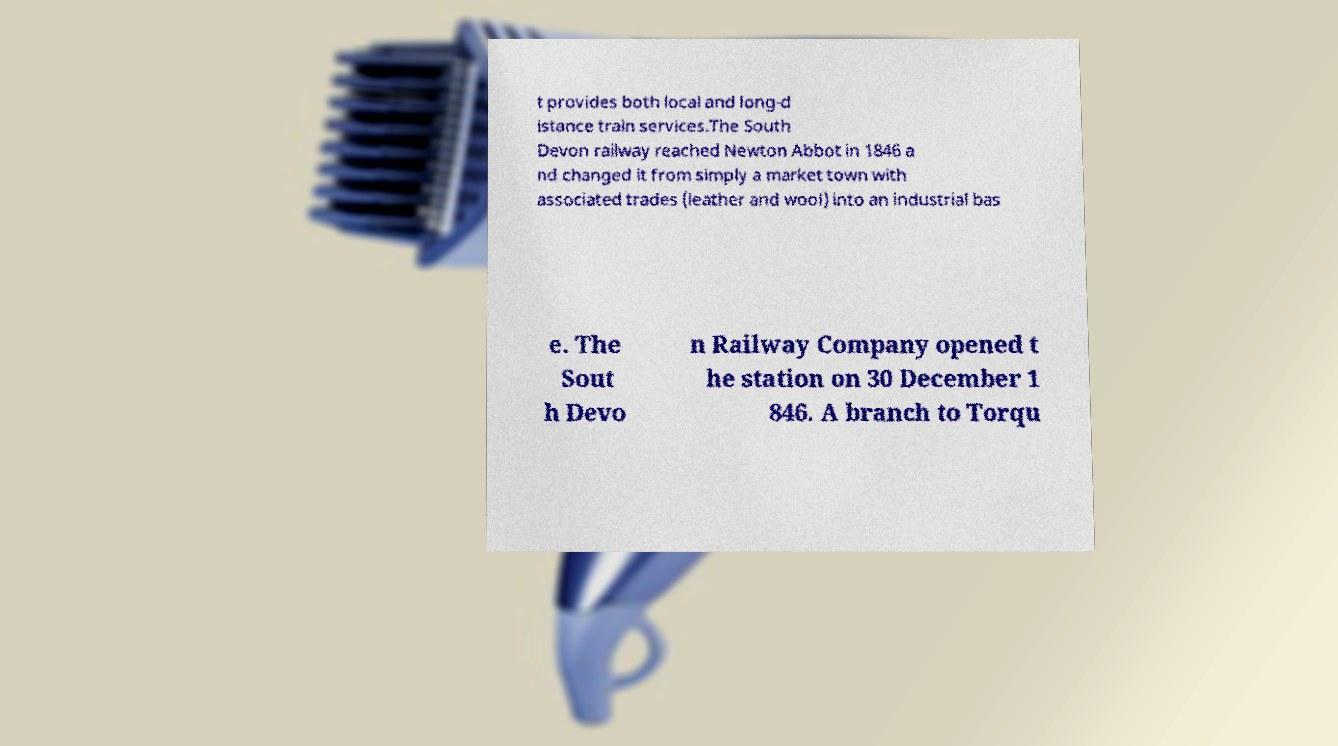I need the written content from this picture converted into text. Can you do that? t provides both local and long-d istance train services.The South Devon railway reached Newton Abbot in 1846 a nd changed it from simply a market town with associated trades (leather and wool) into an industrial bas e. The Sout h Devo n Railway Company opened t he station on 30 December 1 846. A branch to Torqu 